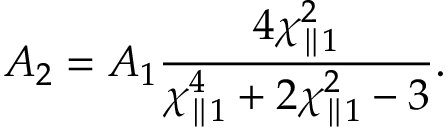<formula> <loc_0><loc_0><loc_500><loc_500>A _ { 2 } = A _ { 1 } \frac { 4 \chi _ { \| 1 } ^ { 2 } } { \chi _ { \| 1 } ^ { 4 } + 2 \chi _ { \| 1 } ^ { 2 } - 3 } .</formula> 